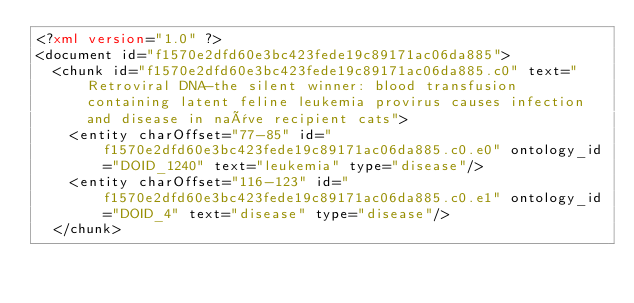Convert code to text. <code><loc_0><loc_0><loc_500><loc_500><_XML_><?xml version="1.0" ?>
<document id="f1570e2dfd60e3bc423fede19c89171ac06da885">
  <chunk id="f1570e2dfd60e3bc423fede19c89171ac06da885.c0" text="Retroviral DNA-the silent winner: blood transfusion containing latent feline leukemia provirus causes infection and disease in naïve recipient cats">
    <entity charOffset="77-85" id="f1570e2dfd60e3bc423fede19c89171ac06da885.c0.e0" ontology_id="DOID_1240" text="leukemia" type="disease"/>
    <entity charOffset="116-123" id="f1570e2dfd60e3bc423fede19c89171ac06da885.c0.e1" ontology_id="DOID_4" text="disease" type="disease"/>
  </chunk></code> 